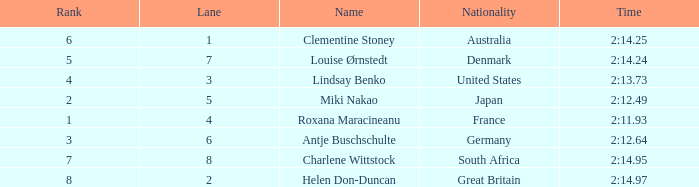What is the number of lane with a rank more than 2 for louise ørnstedt? 1.0. 